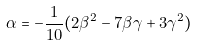Convert formula to latex. <formula><loc_0><loc_0><loc_500><loc_500>\alpha = - \frac { 1 } { 1 0 } ( 2 { \beta } ^ { 2 } - 7 \beta \gamma + 3 { \gamma } ^ { 2 } )</formula> 